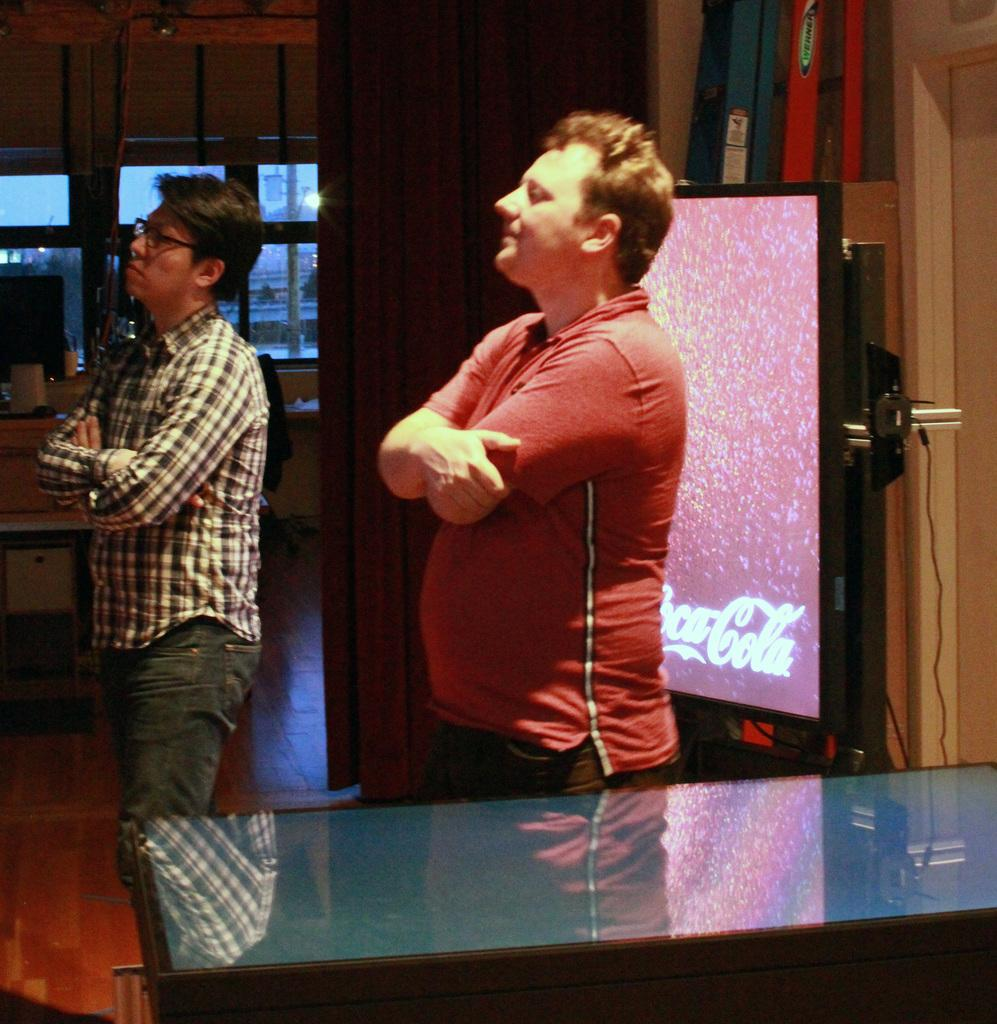How many people are present in the image? There are two persons standing in the image. What can be seen in the image besides the people? There is a table and a display board in the image. What is visible in the background of the image? There is a glass window in the background of the image. What type of butter is being used to start the sugar in the image? There is no butter or sugar present in the image, and therefore no such activity can be observed. 